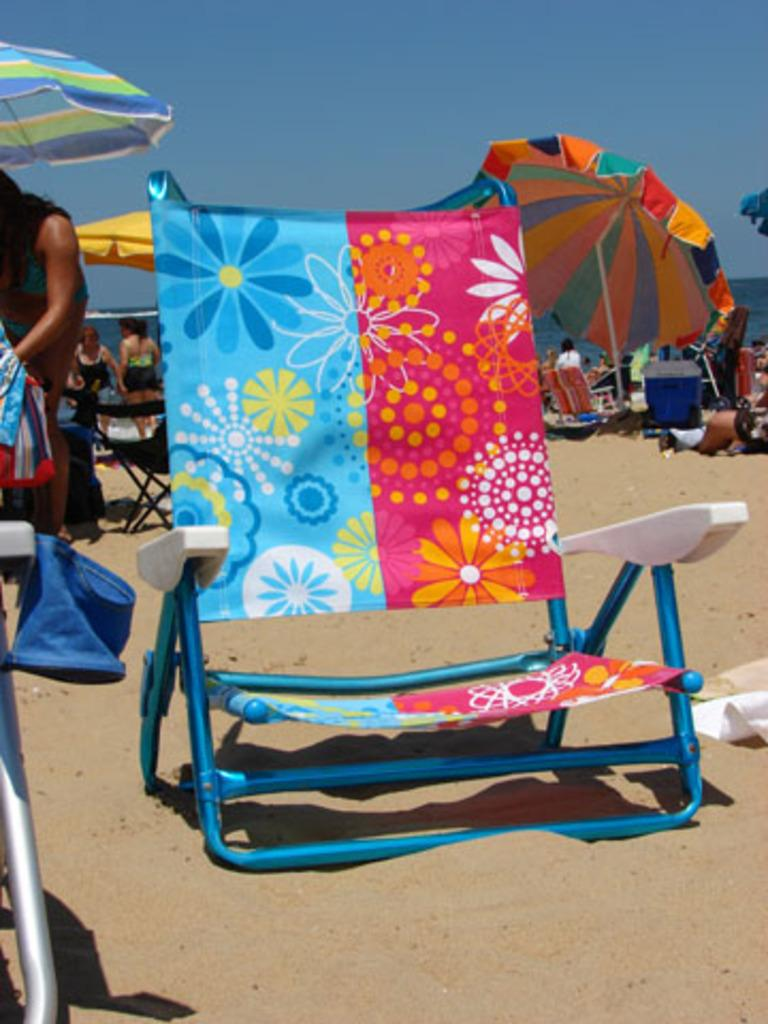What is located on the sand in the foreground of the image? There is a chair on the sand in the foreground of the image. Can you describe the people in the image? There are people in the image, but their specific actions or appearances are not mentioned in the facts. How many chairs are visible in the image? There are chairs in the image, but the exact number is not specified in the facts. What type of shelter is provided in the image? There are umbrellas in the image, which can provide shelter from the sun. What is the general setting of the image? The setting appears to be a beach, as indicated by the presence of sand and umbrellas. What can be seen in the background of the image? The sky is visible in the background of the image. What type of list is being used by the people on the beach in the image? There is no mention of a list in the image or the provided facts. What event is taking place on the beach in the image? The image does not depict a specific event; it simply shows people and chairs on a beach. 